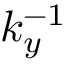<formula> <loc_0><loc_0><loc_500><loc_500>k _ { y } ^ { - 1 }</formula> 